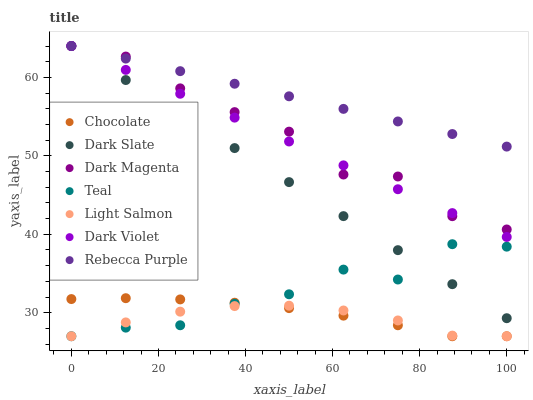Does Light Salmon have the minimum area under the curve?
Answer yes or no. Yes. Does Rebecca Purple have the maximum area under the curve?
Answer yes or no. Yes. Does Dark Magenta have the minimum area under the curve?
Answer yes or no. No. Does Dark Magenta have the maximum area under the curve?
Answer yes or no. No. Is Dark Violet the smoothest?
Answer yes or no. Yes. Is Teal the roughest?
Answer yes or no. Yes. Is Dark Magenta the smoothest?
Answer yes or no. No. Is Dark Magenta the roughest?
Answer yes or no. No. Does Light Salmon have the lowest value?
Answer yes or no. Yes. Does Dark Magenta have the lowest value?
Answer yes or no. No. Does Rebecca Purple have the highest value?
Answer yes or no. Yes. Does Chocolate have the highest value?
Answer yes or no. No. Is Light Salmon less than Dark Slate?
Answer yes or no. Yes. Is Rebecca Purple greater than Chocolate?
Answer yes or no. Yes. Does Dark Magenta intersect Rebecca Purple?
Answer yes or no. Yes. Is Dark Magenta less than Rebecca Purple?
Answer yes or no. No. Is Dark Magenta greater than Rebecca Purple?
Answer yes or no. No. Does Light Salmon intersect Dark Slate?
Answer yes or no. No. 